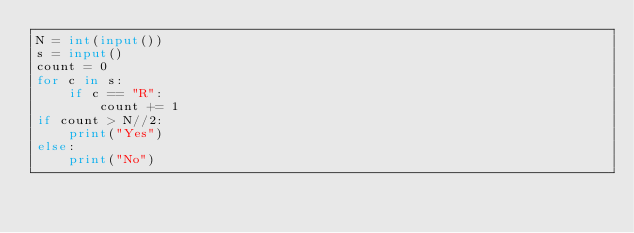<code> <loc_0><loc_0><loc_500><loc_500><_Python_>N = int(input())
s = input()
count = 0
for c in s:
    if c == "R":
        count += 1
if count > N//2:
    print("Yes")
else:
    print("No")
</code> 